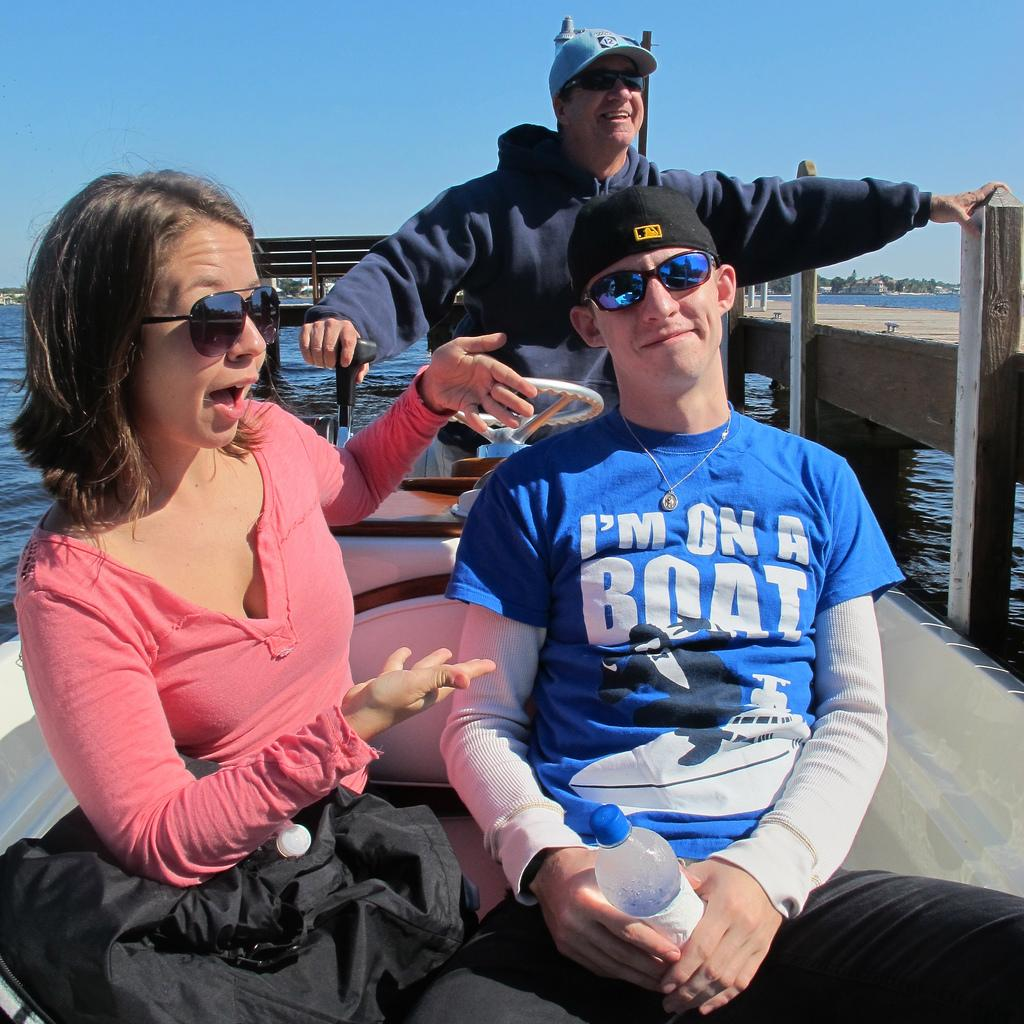<image>
Share a concise interpretation of the image provided. A guy on a boat has a shirt that says I'm on a boat on it. 